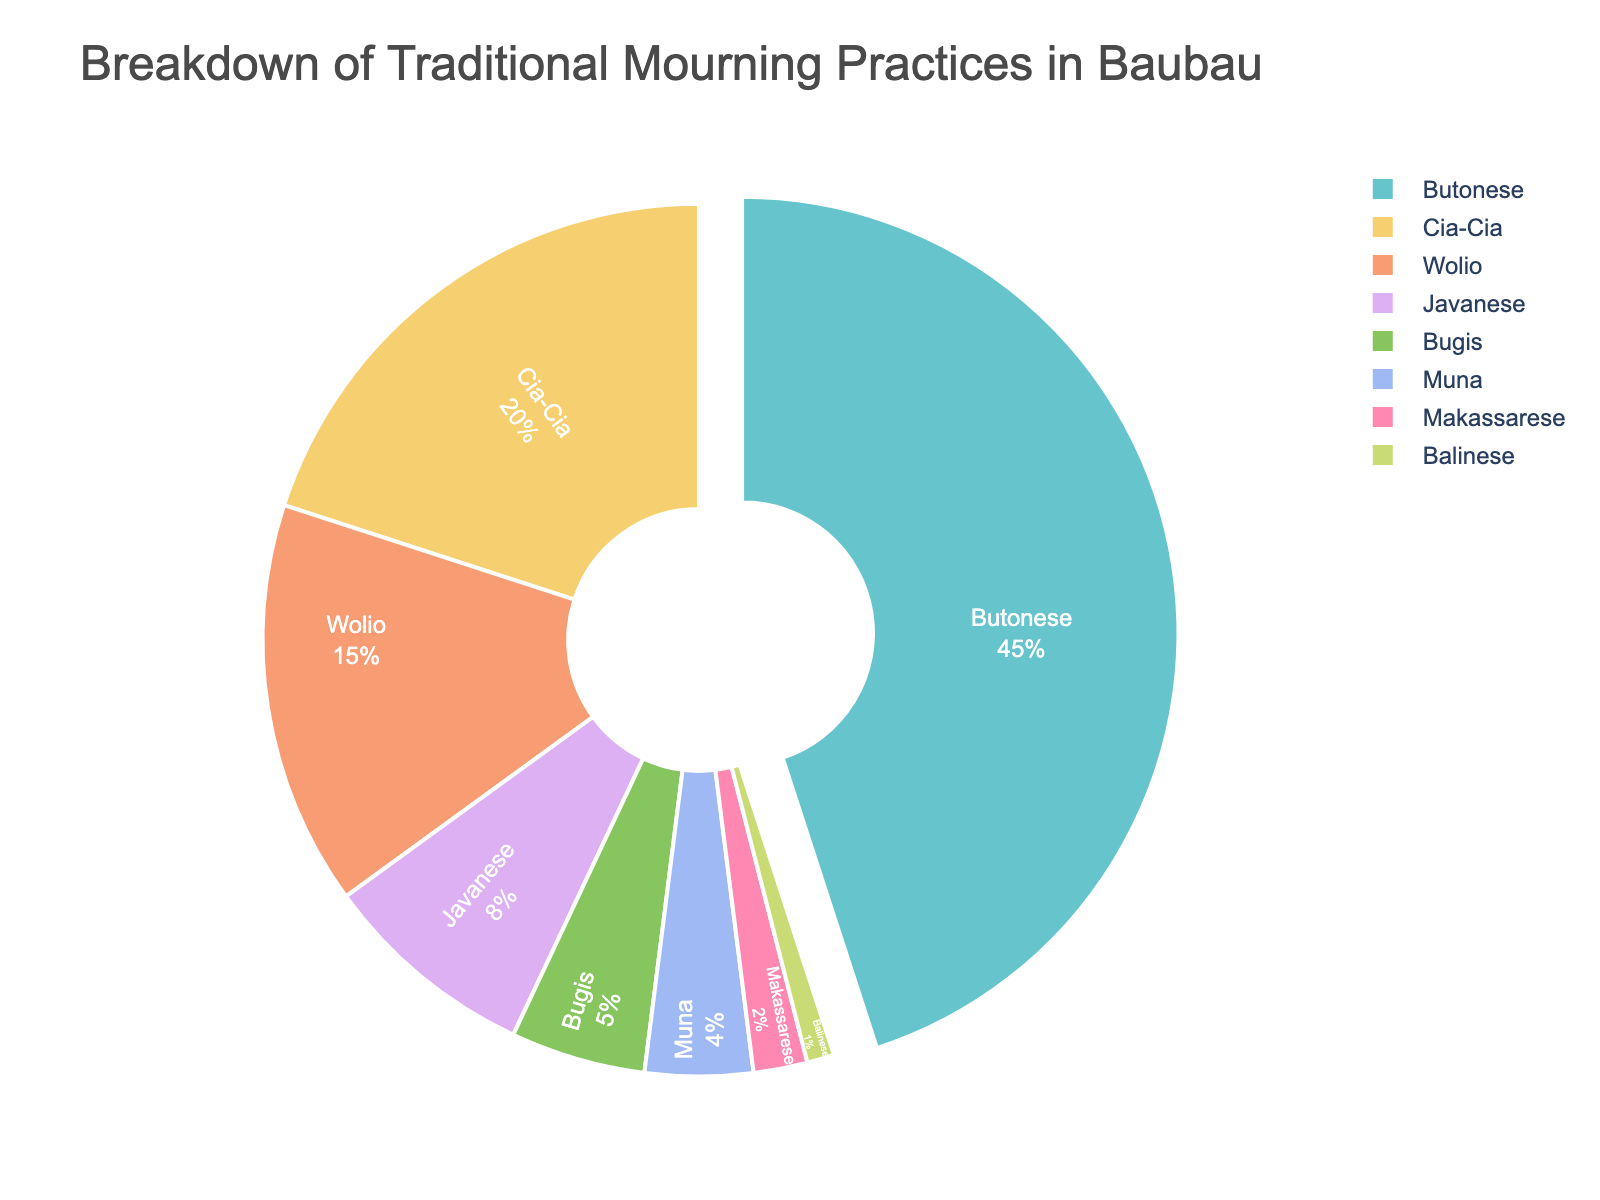Which ethnic group observes the most traditional mourning practices? By looking at the pie chart, it is evident that the Butonese ethnic group has the largest portion of the pie. Specifically, the section for the Butonese is indicated to be the largest with a 45% share of the practices.
Answer: Butonese Which two ethnic groups combined make up more than 50% of the traditional mourning practices? To find the combined percentage, look at the data for the two largest groups. The Butonese have 45% and the Cia-Cia have 20%. Adding these two together: 45% + 20% = 65%, which is more than 50%.
Answer: Butonese and Cia-Cia Which ethnic groups have less than 5% representation in the pie chart? By examining the percentages listed in the pie chart, we can see that the Bugis (5%), Muna (4%), Makassarese (2%), and Balinese (1%) each have less than 5%.
Answer: Muna, Makassarese, and Balinese What is the total percentage of traditional mourning practices observed by the Wolio and Javanese ethnic groups? Looking at the pie chart, we can see that the Wolio have 15% and the Javanese have 8%. Adding these together: 15% + 8% = 23%.
Answer: 23% Which ethnic group is represented by the smallest section in the pie chart? To determine this, look for the smallest percentage. The Balinese ethnic group is represented by the smallest section with only 1%.
Answer: Balinese Are the combined percentages of Muna and Makassarese less than the percentage observed by the Wolio ethnic group? The Muna have 4% and the Makassarese have 2%. Adding these together gives 4% + 2% = 6%. The Wolio have 15%, and 6% < 15%. Thus, the combined percentages of Muna and Makassarese are indeed less than that of the Wolio.
Answer: Yes What percentage of traditional mourning practices is represented by the Javanese and Bugis ethnic groups together? The pie chart reveals that the Javanese have 8% and the Bugis have 5%. Adding these together, 8% + 5% = 13%.
Answer: 13% Which ethnic groups have sections that are visually distinct due to being "pulled out" from the rest of the pie? Observing the visual representation, the only section that is "pulled out" is for the ethnic group with the highest percentage. In this case, it is the Butonese ethnic group’s section that is "pulled out."
Answer: Butonese How does the representation of the Cia-Cia ethnic group compare to that of the Bugis ethnic group in terms of their slice sizes? The pie chart shows that the Cia-Cia have a 20% portion while the Bugis have a 5% portion. Comparing these two, 20% is indeed larger than 5%, meaning the Cia-Cia have a larger slice than the Bugis.
Answer: Cia-Cia has a larger slice than Bugis 